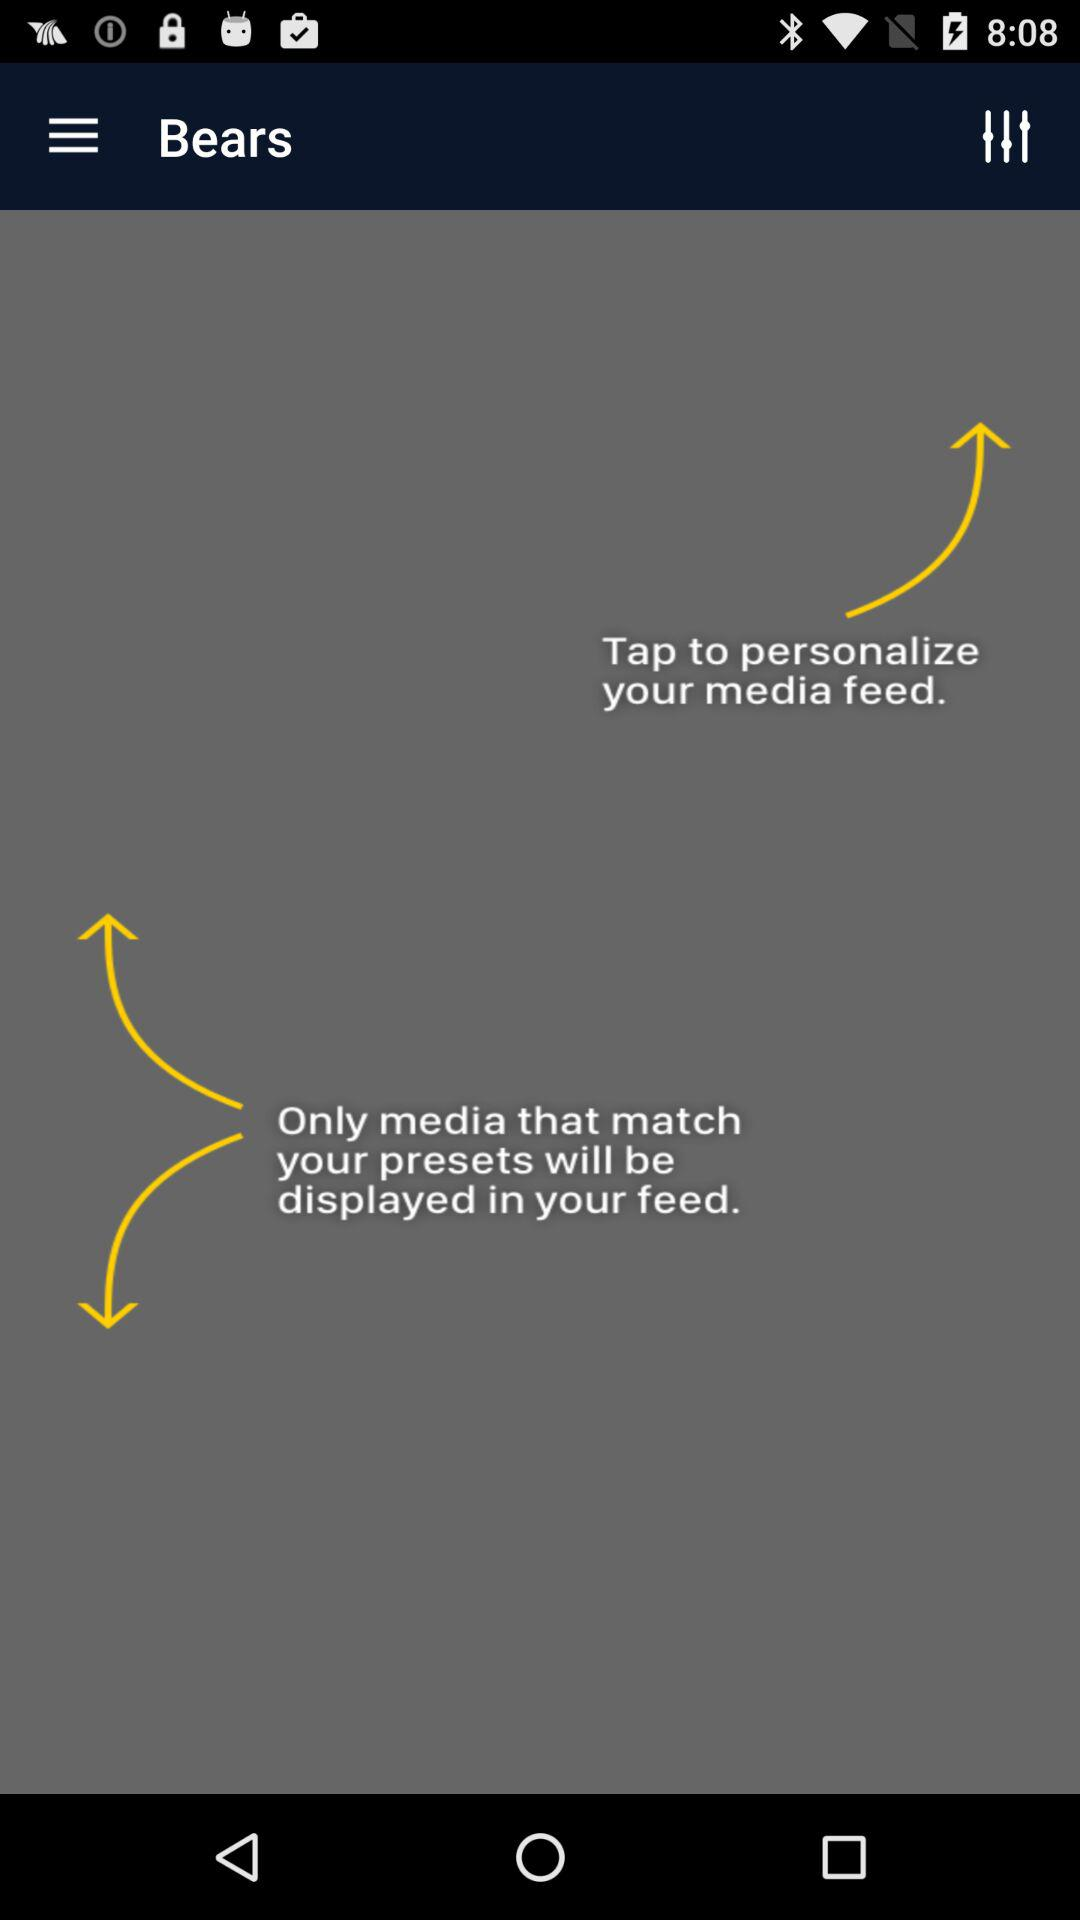What is the application name? The application name is "Bears". 